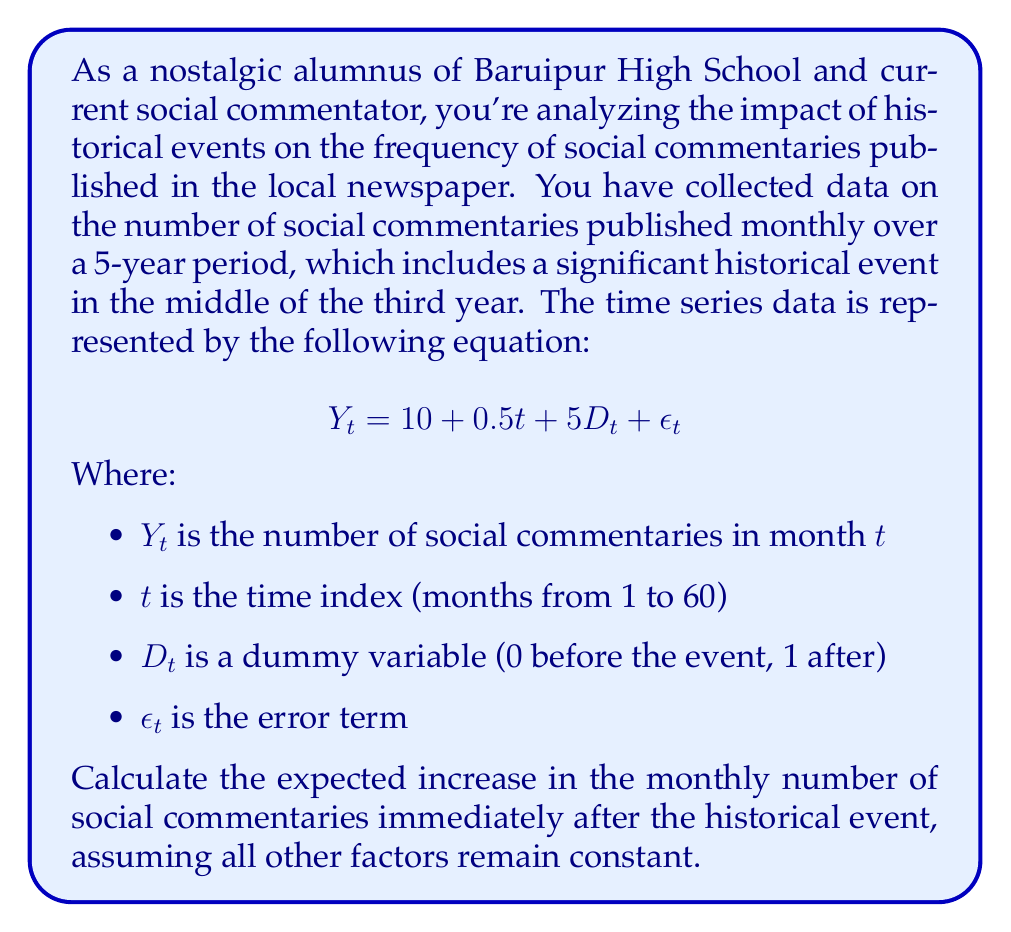Help me with this question. To solve this problem, we need to understand the components of the given time series equation and how they relate to the question at hand. Let's break it down step-by-step:

1. Understand the equation:
   $$Y_t = 10 + 0.5t + 5D_t + \epsilon_t$$

   - 10 is the constant term (baseline number of commentaries)
   - 0.5t represents the trend component (gradual increase over time)
   - 5D_t is the impact of the historical event
   - $\epsilon_t$ is the error term (random fluctuations)

2. Identify the component representing the historical event's impact:
   The term $5D_t$ represents the impact of the historical event, where:
   - $D_t = 0$ before the event
   - $D_t = 1$ after the event

3. Calculate the change in $Y_t$ due to the historical event:
   Before the event: $5D_t = 5 * 0 = 0$
   After the event: $5D_t = 5 * 1 = 5$

4. Determine the increase:
   The difference between after and before the event is 5 - 0 = 5

Therefore, the expected increase in the monthly number of social commentaries immediately after the historical event is 5, assuming all other factors remain constant.
Answer: 5 commentaries 